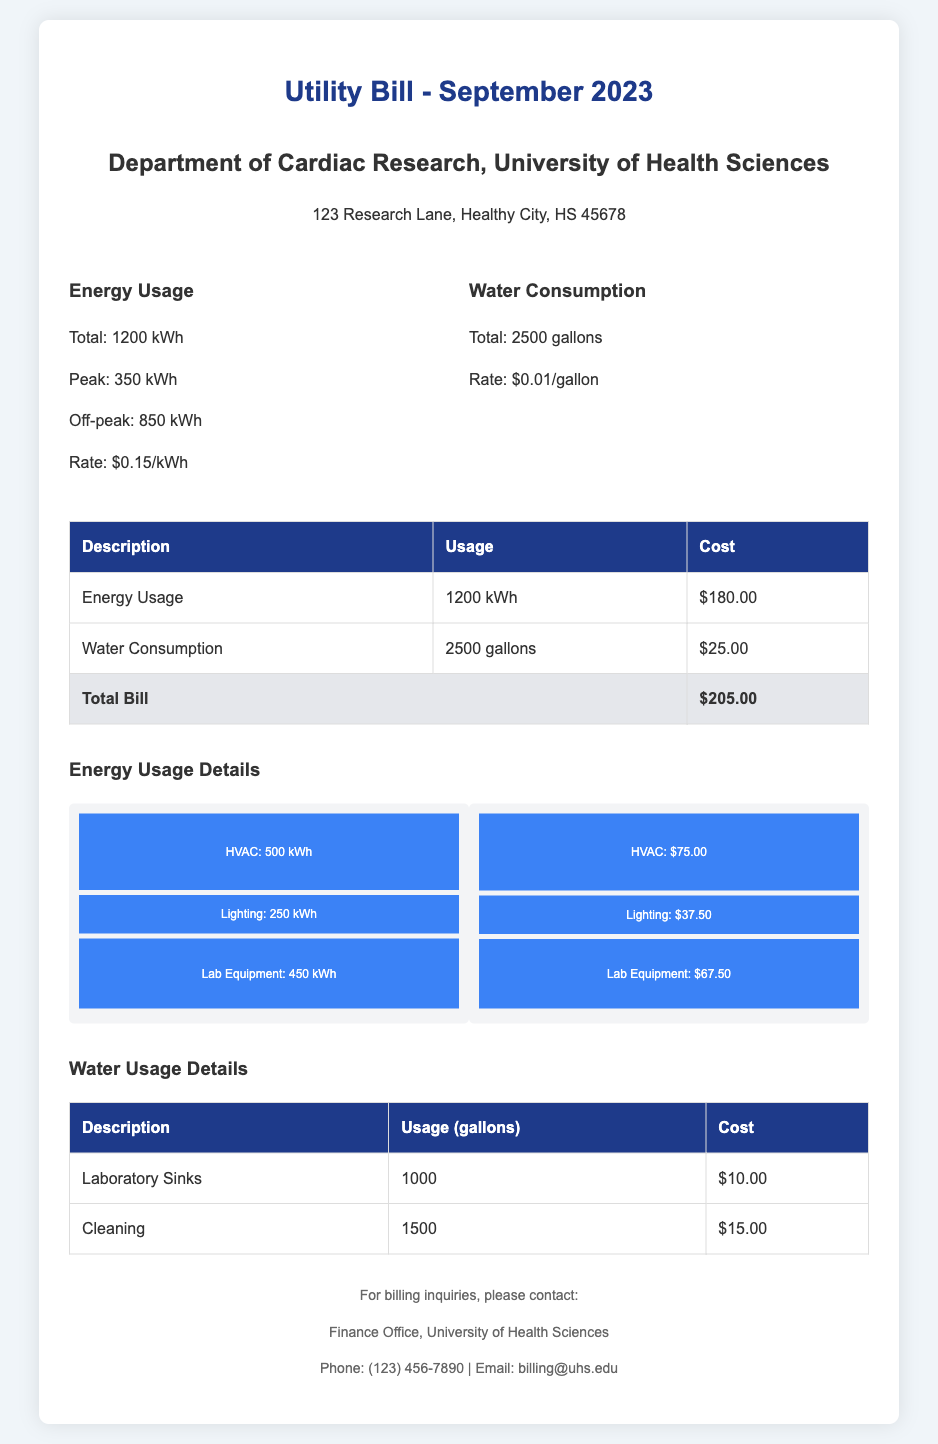What is the total energy usage? The total energy usage is directly stated in the document as 1200 kWh.
Answer: 1200 kWh What is the peak energy usage? The peak energy usage is listed as 350 kWh in the document.
Answer: 350 kWh What is the total water consumption? The document mentions the total water consumption as 2500 gallons.
Answer: 2500 gallons What is the total cost of the bill? The total cost of the bill is clearly indicated as $205.00 in the document.
Answer: $205.00 How much is the rate for energy per kWh? The rate for energy is provided in the document as $0.15 per kWh.
Answer: $0.15/kWh What is the cost for water consumption? The document specifies the cost for water consumption as $25.00.
Answer: $25.00 Which category consumed the most energy? The energy usage details indicate that HVAC consumed the most energy at 500 kWh.
Answer: HVAC What is the usage of laboratory sinks? The document states that the usage of laboratory sinks is 1000 gallons.
Answer: 1000 gallons What is the contact email for billing inquiries? The document includes the contact email for billing inquiries as billing@uhs.edu.
Answer: billing@uhs.edu 